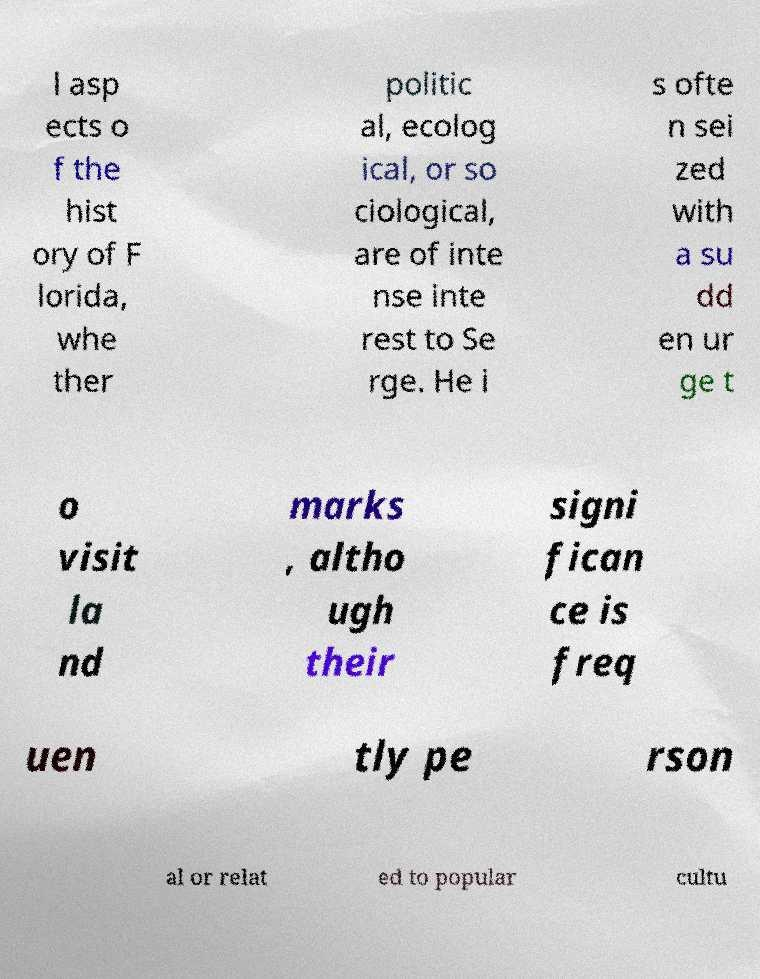Could you extract and type out the text from this image? l asp ects o f the hist ory of F lorida, whe ther politic al, ecolog ical, or so ciological, are of inte nse inte rest to Se rge. He i s ofte n sei zed with a su dd en ur ge t o visit la nd marks , altho ugh their signi fican ce is freq uen tly pe rson al or relat ed to popular cultu 